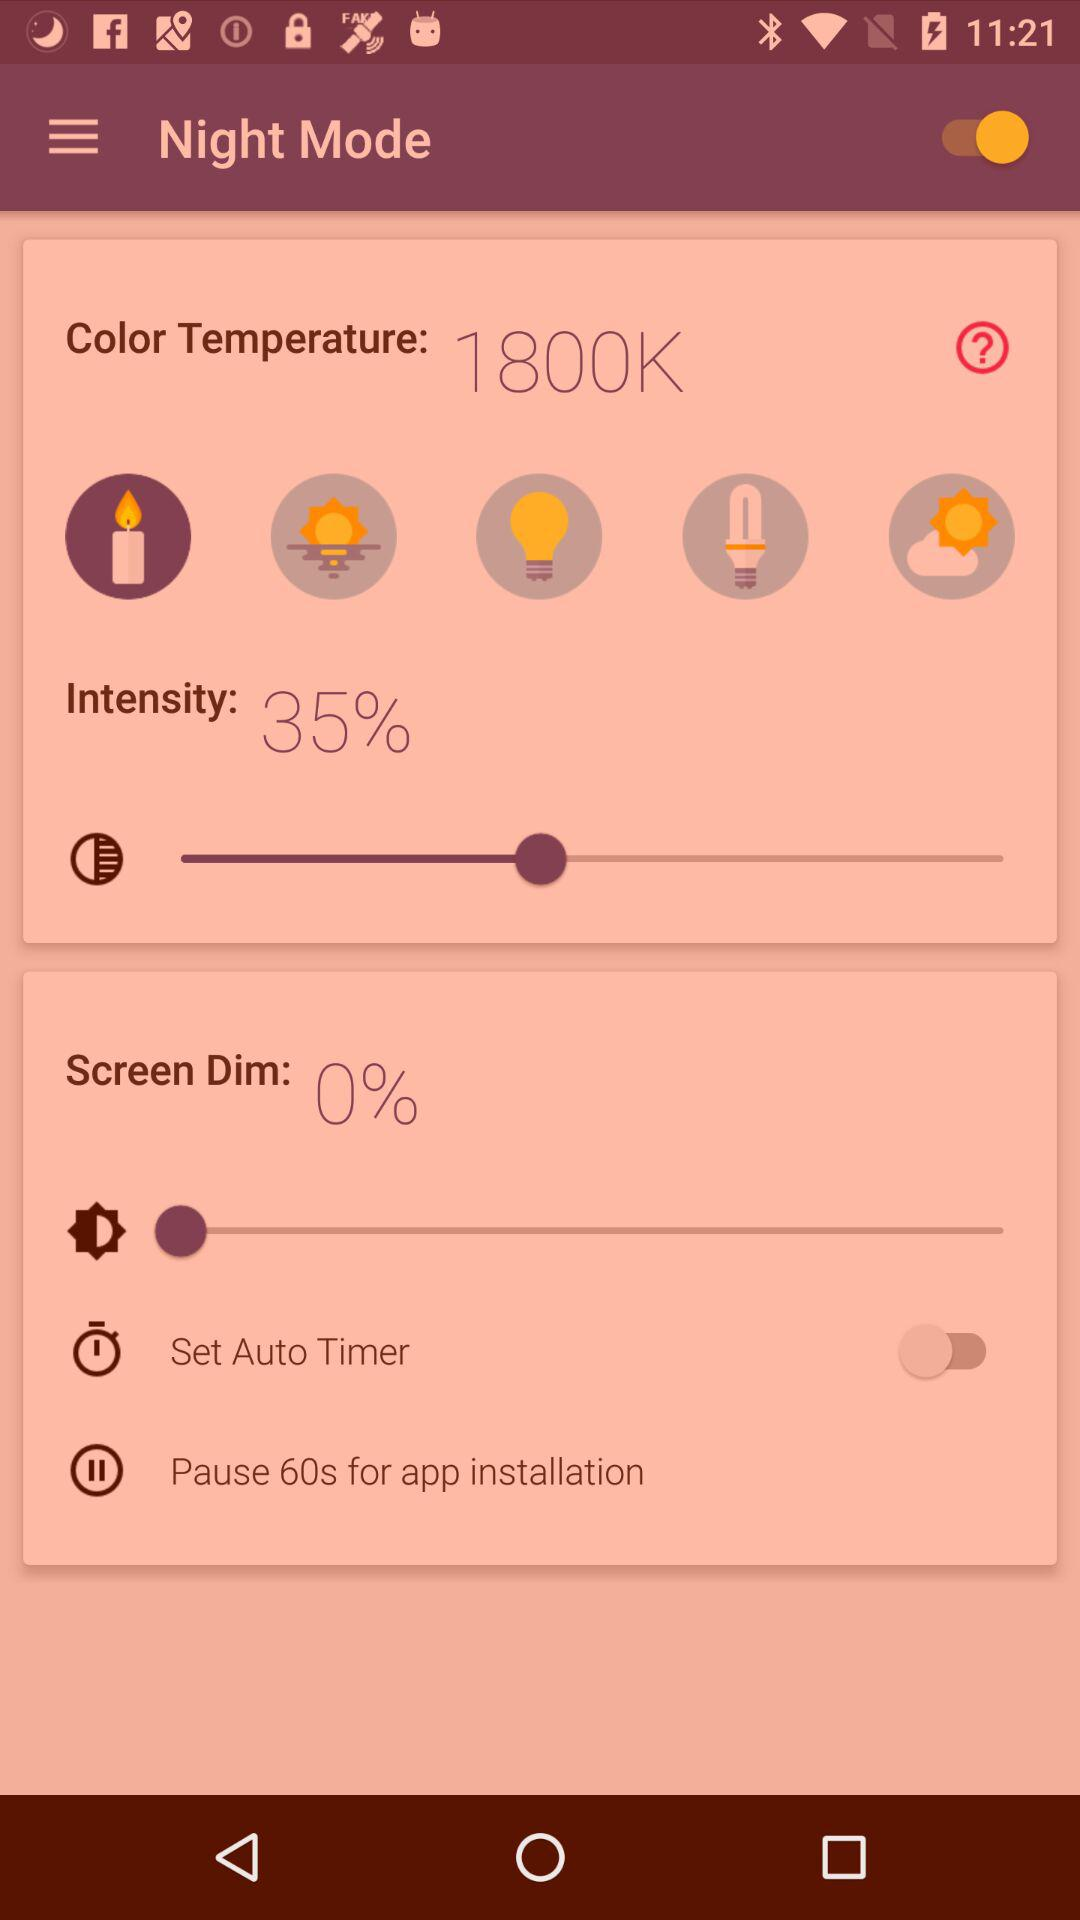What is the status of the "Set Auto Timer"? The status is "off". 